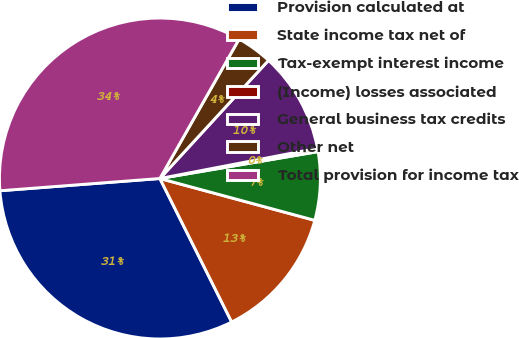<chart> <loc_0><loc_0><loc_500><loc_500><pie_chart><fcel>Provision calculated at<fcel>State income tax net of<fcel>Tax-exempt interest income<fcel>(Income) losses associated<fcel>General business tax credits<fcel>Other net<fcel>Total provision for income tax<nl><fcel>31.17%<fcel>13.42%<fcel>6.88%<fcel>0.34%<fcel>10.15%<fcel>3.61%<fcel>34.44%<nl></chart> 